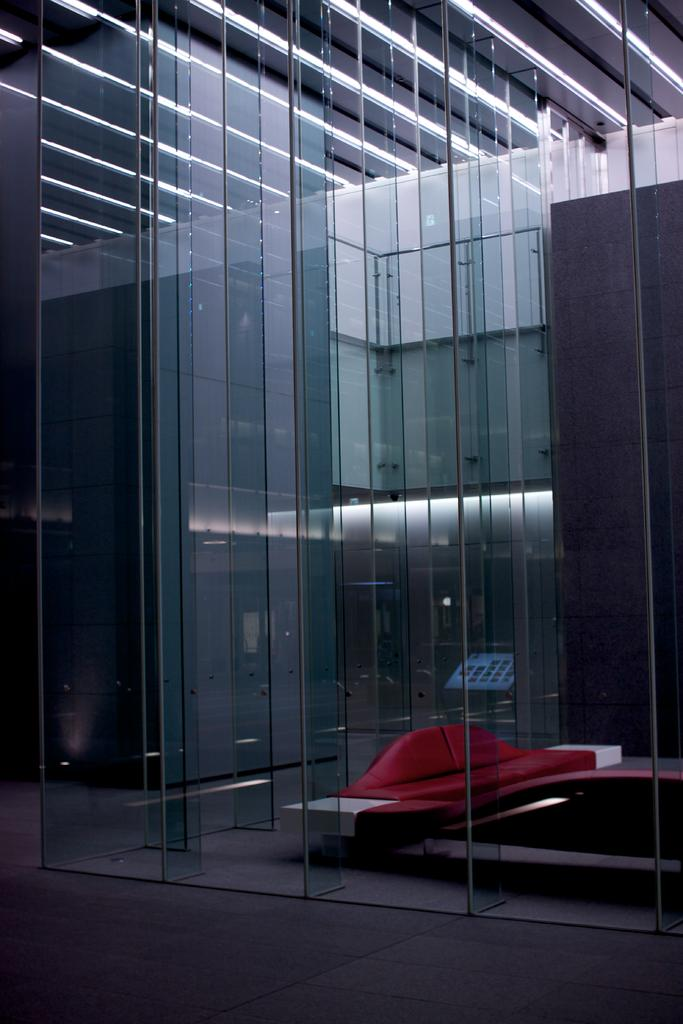What type of structure is in the image? There is a cabin in the image. What objects can be seen inside the cabin? There are glasses in the image. What is visible through the glasses? A couch is visible through the glasses. What type of lettuce is being processed in the image? There is no lettuce or process visible in the image; it only features a cabin, glasses, and a couch. 